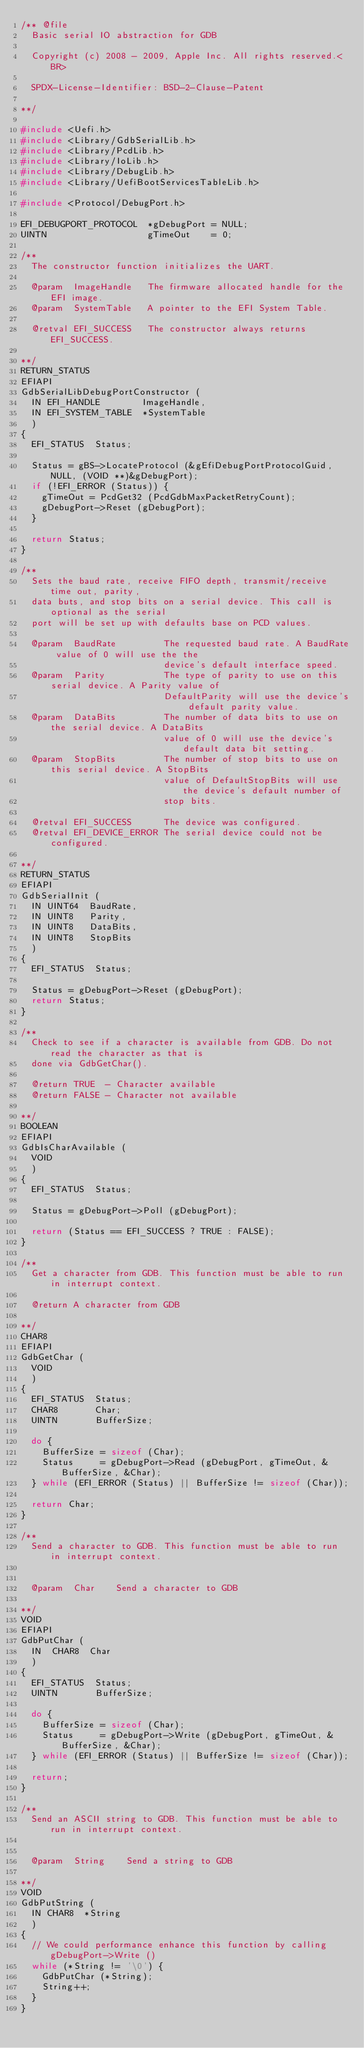Convert code to text. <code><loc_0><loc_0><loc_500><loc_500><_C_>/** @file
  Basic serial IO abstraction for GDB

  Copyright (c) 2008 - 2009, Apple Inc. All rights reserved.<BR>

  SPDX-License-Identifier: BSD-2-Clause-Patent

**/

#include <Uefi.h>
#include <Library/GdbSerialLib.h>
#include <Library/PcdLib.h>
#include <Library/IoLib.h>
#include <Library/DebugLib.h>
#include <Library/UefiBootServicesTableLib.h>

#include <Protocol/DebugPort.h>

EFI_DEBUGPORT_PROTOCOL  *gDebugPort = NULL;
UINTN                   gTimeOut    = 0;

/**
  The constructor function initializes the UART.

  @param  ImageHandle   The firmware allocated handle for the EFI image.
  @param  SystemTable   A pointer to the EFI System Table.

  @retval EFI_SUCCESS   The constructor always returns EFI_SUCCESS.

**/
RETURN_STATUS
EFIAPI
GdbSerialLibDebugPortConstructor (
  IN EFI_HANDLE        ImageHandle,
  IN EFI_SYSTEM_TABLE  *SystemTable
  )
{
  EFI_STATUS  Status;

  Status = gBS->LocateProtocol (&gEfiDebugPortProtocolGuid, NULL, (VOID **)&gDebugPort);
  if (!EFI_ERROR (Status)) {
    gTimeOut = PcdGet32 (PcdGdbMaxPacketRetryCount);
    gDebugPort->Reset (gDebugPort);
  }

  return Status;
}

/**
  Sets the baud rate, receive FIFO depth, transmit/receive time out, parity,
  data buts, and stop bits on a serial device. This call is optional as the serial
  port will be set up with defaults base on PCD values.

  @param  BaudRate         The requested baud rate. A BaudRate value of 0 will use the the
                           device's default interface speed.
  @param  Parity           The type of parity to use on this serial device. A Parity value of
                           DefaultParity will use the device's default parity value.
  @param  DataBits         The number of data bits to use on the serial device. A DataBits
                           value of 0 will use the device's default data bit setting.
  @param  StopBits         The number of stop bits to use on this serial device. A StopBits
                           value of DefaultStopBits will use the device's default number of
                           stop bits.

  @retval EFI_SUCCESS      The device was configured.
  @retval EFI_DEVICE_ERROR The serial device could not be configured.

**/
RETURN_STATUS
EFIAPI
GdbSerialInit (
  IN UINT64  BaudRate,
  IN UINT8   Parity,
  IN UINT8   DataBits,
  IN UINT8   StopBits
  )
{
  EFI_STATUS  Status;

  Status = gDebugPort->Reset (gDebugPort);
  return Status;
}

/**
  Check to see if a character is available from GDB. Do not read the character as that is
  done via GdbGetChar().

  @return TRUE  - Character available
  @return FALSE - Character not available

**/
BOOLEAN
EFIAPI
GdbIsCharAvailable (
  VOID
  )
{
  EFI_STATUS  Status;

  Status = gDebugPort->Poll (gDebugPort);

  return (Status == EFI_SUCCESS ? TRUE : FALSE);
}

/**
  Get a character from GDB. This function must be able to run in interrupt context.

  @return A character from GDB

**/
CHAR8
EFIAPI
GdbGetChar (
  VOID
  )
{
  EFI_STATUS  Status;
  CHAR8       Char;
  UINTN       BufferSize;

  do {
    BufferSize = sizeof (Char);
    Status     = gDebugPort->Read (gDebugPort, gTimeOut, &BufferSize, &Char);
  } while (EFI_ERROR (Status) || BufferSize != sizeof (Char));

  return Char;
}

/**
  Send a character to GDB. This function must be able to run in interrupt context.


  @param  Char    Send a character to GDB

**/
VOID
EFIAPI
GdbPutChar (
  IN  CHAR8  Char
  )
{
  EFI_STATUS  Status;
  UINTN       BufferSize;

  do {
    BufferSize = sizeof (Char);
    Status     = gDebugPort->Write (gDebugPort, gTimeOut, &BufferSize, &Char);
  } while (EFI_ERROR (Status) || BufferSize != sizeof (Char));

  return;
}

/**
  Send an ASCII string to GDB. This function must be able to run in interrupt context.


  @param  String    Send a string to GDB

**/
VOID
GdbPutString (
  IN CHAR8  *String
  )
{
  // We could performance enhance this function by calling gDebugPort->Write ()
  while (*String != '\0') {
    GdbPutChar (*String);
    String++;
  }
}
</code> 